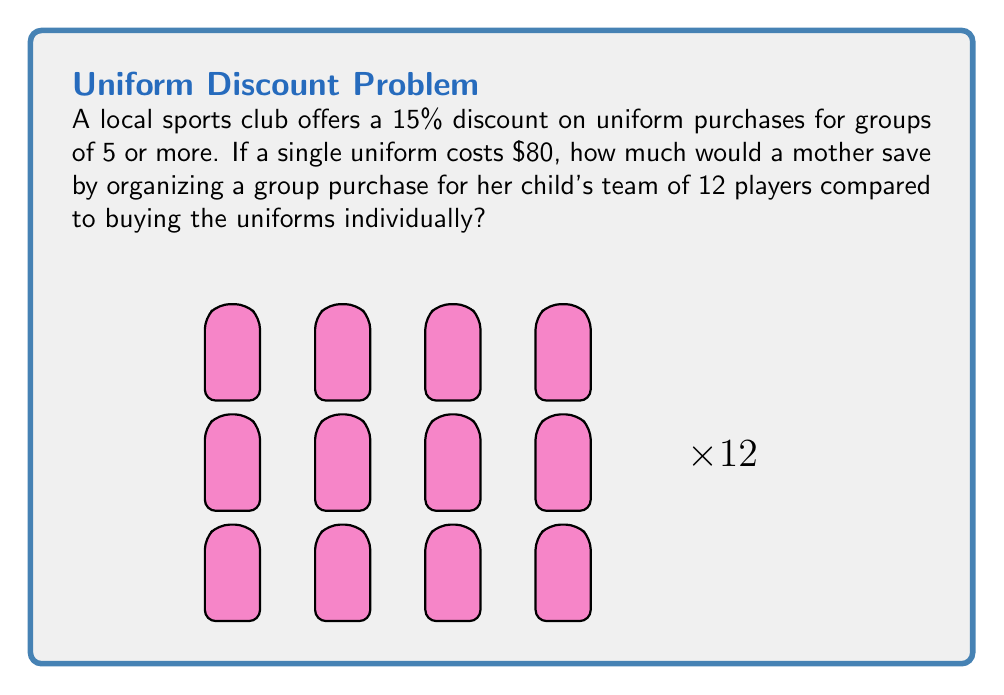Show me your answer to this math problem. Let's approach this step-by-step:

1) First, calculate the cost of buying 12 uniforms individually:
   $$12 \times $80 = $960$$

2) Now, calculate the discounted price for a group purchase:
   - The discount is 15%, so the new price per uniform is:
   $$80 - (80 \times 0.15) = 80 - 12 = $68$$

3) Calculate the total cost for 12 uniforms at the discounted price:
   $$12 \times $68 = $816$$

4) To find the savings, subtract the group purchase cost from the individual purchase cost:
   $$960 - 816 = $144$$

Therefore, by organizing a group purchase, the mother would save $144 for the team.
Answer: $144 